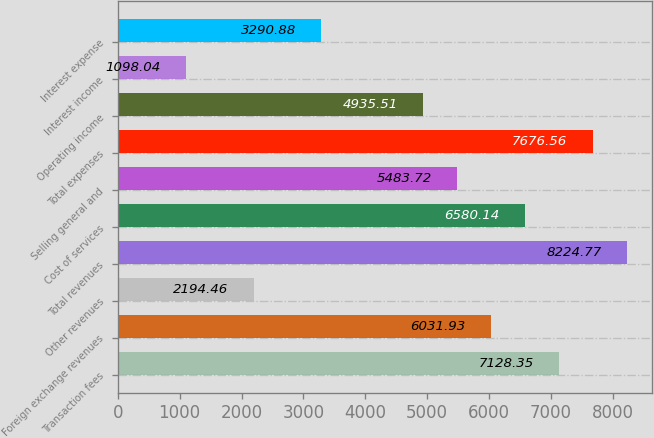<chart> <loc_0><loc_0><loc_500><loc_500><bar_chart><fcel>Transaction fees<fcel>Foreign exchange revenues<fcel>Other revenues<fcel>Total revenues<fcel>Cost of services<fcel>Selling general and<fcel>Total expenses<fcel>Operating income<fcel>Interest income<fcel>Interest expense<nl><fcel>7128.35<fcel>6031.93<fcel>2194.46<fcel>8224.77<fcel>6580.14<fcel>5483.72<fcel>7676.56<fcel>4935.51<fcel>1098.04<fcel>3290.88<nl></chart> 